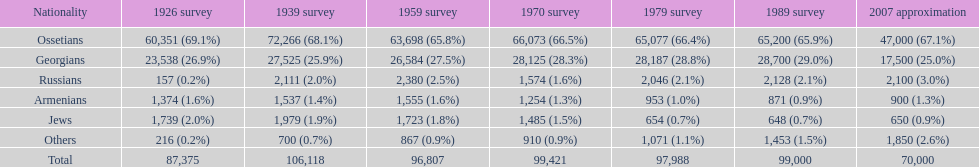How many ethnicity is there? 6. 